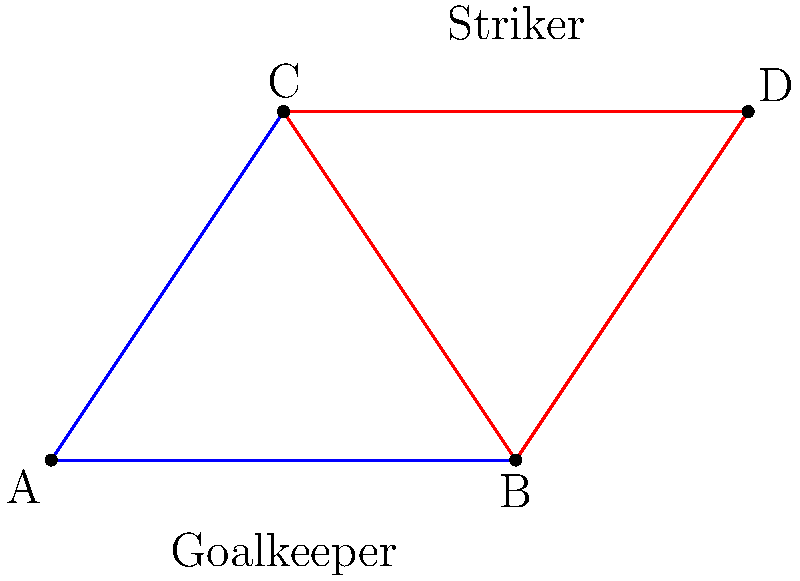During a football match, you notice that the goalkeeper, two defenders, and a striker form two triangles on the pitch as shown in the diagram. Triangle ABC represents the formation of the goalkeeper and two defenders, while triangle BCD represents the formation of two defenders and the striker. Are these two triangles congruent? If so, which congruence criterion proves this? To determine if triangles ABC and BCD are congruent, we need to examine their sides and angles:

1. Side BC is common to both triangles.

2. In triangle ABC:
   - AB is the distance between the goalkeeper and one defender
   - AC is the distance between the goalkeeper and the other defender

3. In triangle BCD:
   - BD is the distance between one defender and the striker
   - CD is the distance between the other defender and the striker

4. Visually, we can see that AB = BD and AC = CD. This is because the striker (point D) is positioned directly above the goalkeeper (point A), forming a rectangle ABCD.

5. Since we have established that:
   - BC is common to both triangles
   - AB = BD
   - AC = CD

6. We can conclude that these triangles satisfy the Side-Side-Side (SSS) congruence criterion, which states that if three sides of one triangle are equal to three sides of another triangle, then the triangles are congruent.

Therefore, triangles ABC and BCD are congruent, and this can be proven using the SSS congruence criterion.
Answer: Yes, SSS criterion 